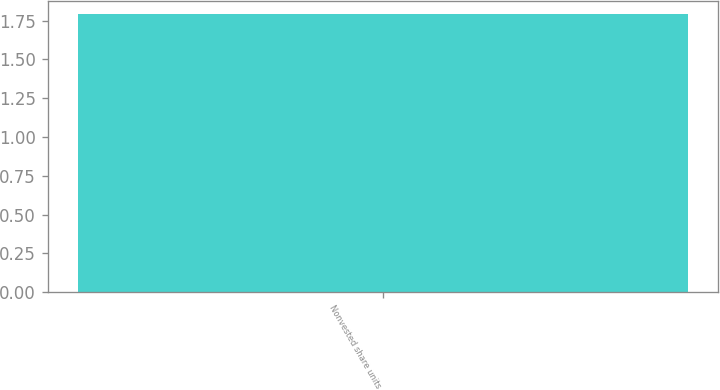Convert chart. <chart><loc_0><loc_0><loc_500><loc_500><bar_chart><fcel>Nonvested share units<nl><fcel>1.79<nl></chart> 